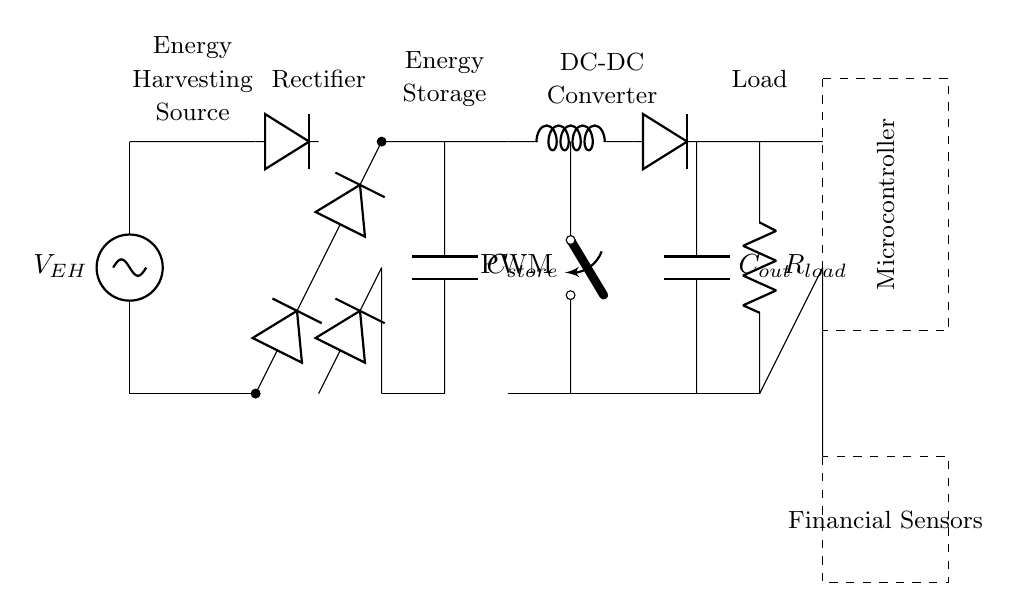What is the source of energy in this circuit? The circuit has an energy harvesting source indicated by the label V_EH at the top. This component captures energy from the environment to power the circuit.
Answer: Energy harvesting source What type of component is used for energy storage? The circuit includes a capacitor labeled C_store, which is used to store energy collected by the energy harvesting source. Capacitors are commonly used for this purpose.
Answer: Capacitor How many diodes are present in the rectifier section? In the rectifier section, there are four diodes shown, indicating the use of a full-wave rectification to convert alternating current to direct current.
Answer: Four What is the purpose of the microcontroller in this circuit? The microcontroller, situated inside the dashed rectangle, coordinates the overall operation of the circuit, processes data from the financial sensors, and manages power consumption.
Answer: Coordinating operation What is likely the output of this circuit? The output is indicated by the load resistor labeled R_load, suggesting that the circuit is designed to supply power to an external device or system, specifically for financial tracking wearables.
Answer: Power supply for wearables What is the function of the PWM switch in the DC-DC converter section? The PWM (Pulse Width Modulation) switch controls the power delivered to the following components by adjusting the duty cycle, which modulates the output voltage and optimizes energy efficiency.
Answer: Voltage modulation How do the sensors relate to the microcontroller? The sensors are connected to the microcontroller, allowing for data collection from the financial sensors, which is processed by the microcontroller to provide insights or actions for the wearable device.
Answer: Data collection 